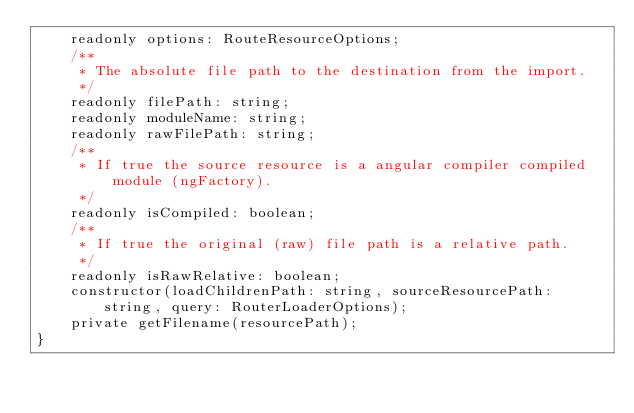<code> <loc_0><loc_0><loc_500><loc_500><_TypeScript_>    readonly options: RouteResourceOptions;
    /**
     * The absolute file path to the destination from the import.
     */
    readonly filePath: string;
    readonly moduleName: string;
    readonly rawFilePath: string;
    /**
     * If true the source resource is a angular compiler compiled module (ngFactory).
     */
    readonly isCompiled: boolean;
    /**
     * If true the original (raw) file path is a relative path.
     */
    readonly isRawRelative: boolean;
    constructor(loadChildrenPath: string, sourceResourcePath: string, query: RouterLoaderOptions);
    private getFilename(resourcePath);
}
</code> 